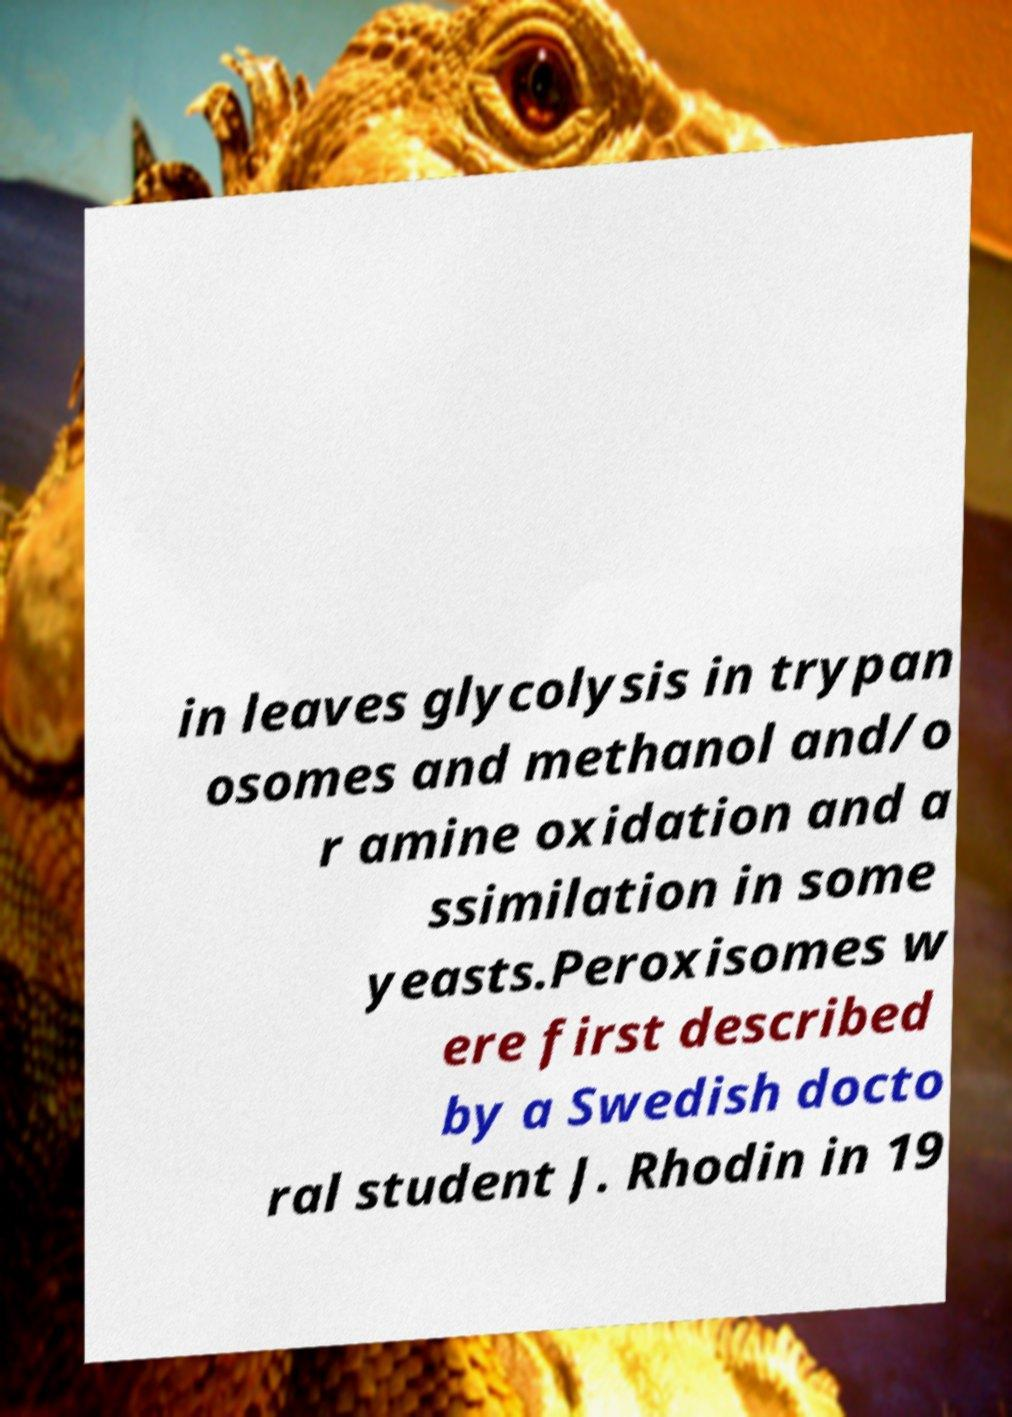Please read and relay the text visible in this image. What does it say? in leaves glycolysis in trypan osomes and methanol and/o r amine oxidation and a ssimilation in some yeasts.Peroxisomes w ere first described by a Swedish docto ral student J. Rhodin in 19 